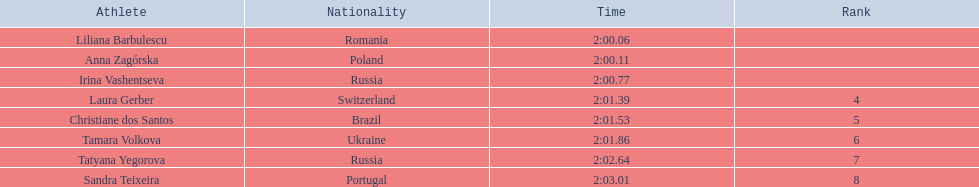Which athletes competed in the 2003 summer universiade - women's 800 metres? Liliana Barbulescu, Anna Zagórska, Irina Vashentseva, Laura Gerber, Christiane dos Santos, Tamara Volkova, Tatyana Yegorova, Sandra Teixeira. Of these, which are from poland? Anna Zagórska. What is her time? 2:00.11. 